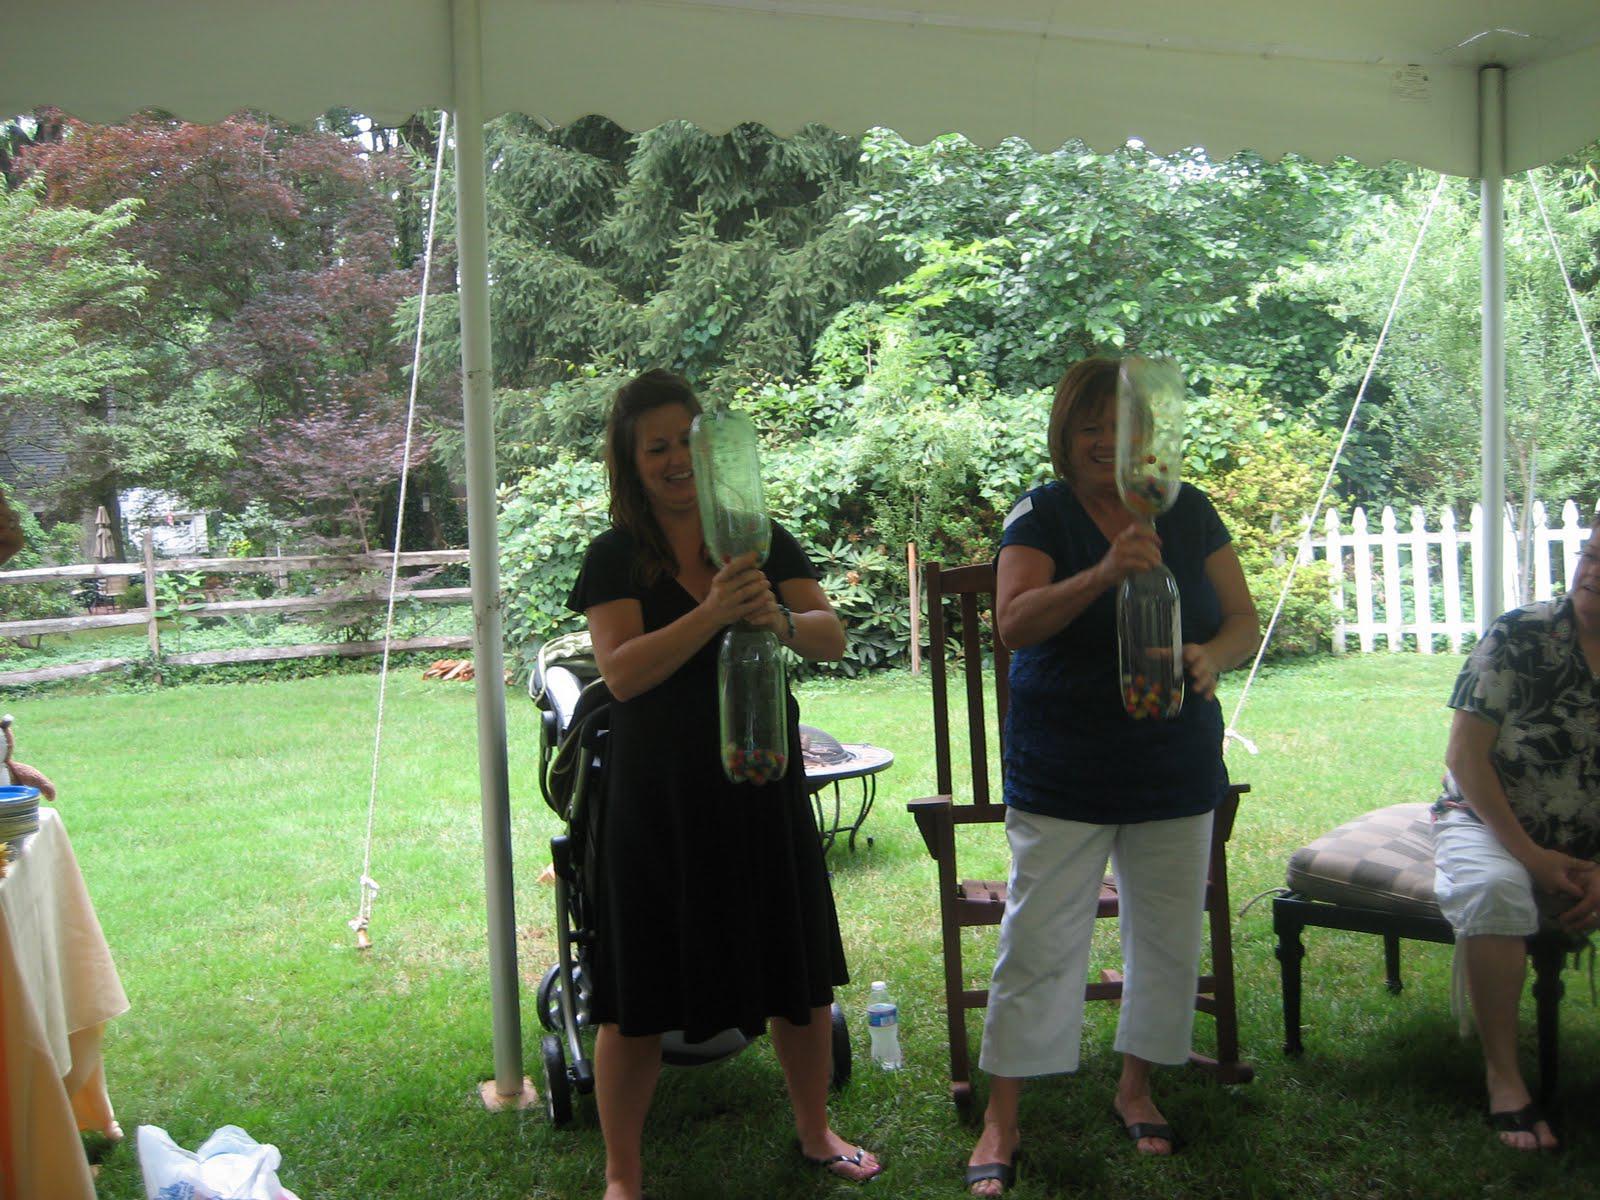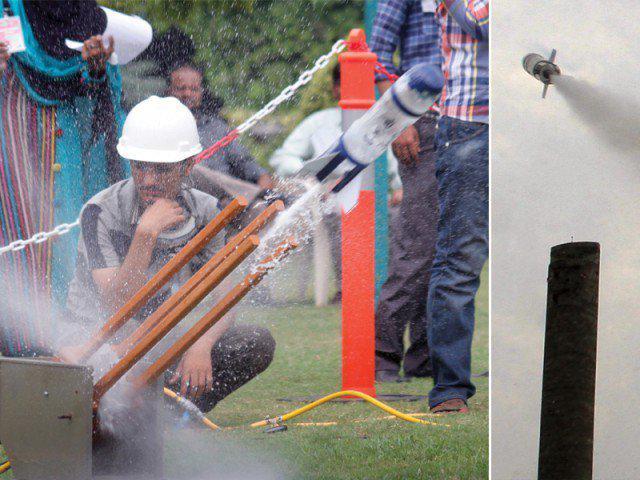The first image is the image on the left, the second image is the image on the right. Evaluate the accuracy of this statement regarding the images: "Both images contain walls made of bottles.". Is it true? Answer yes or no. No. 